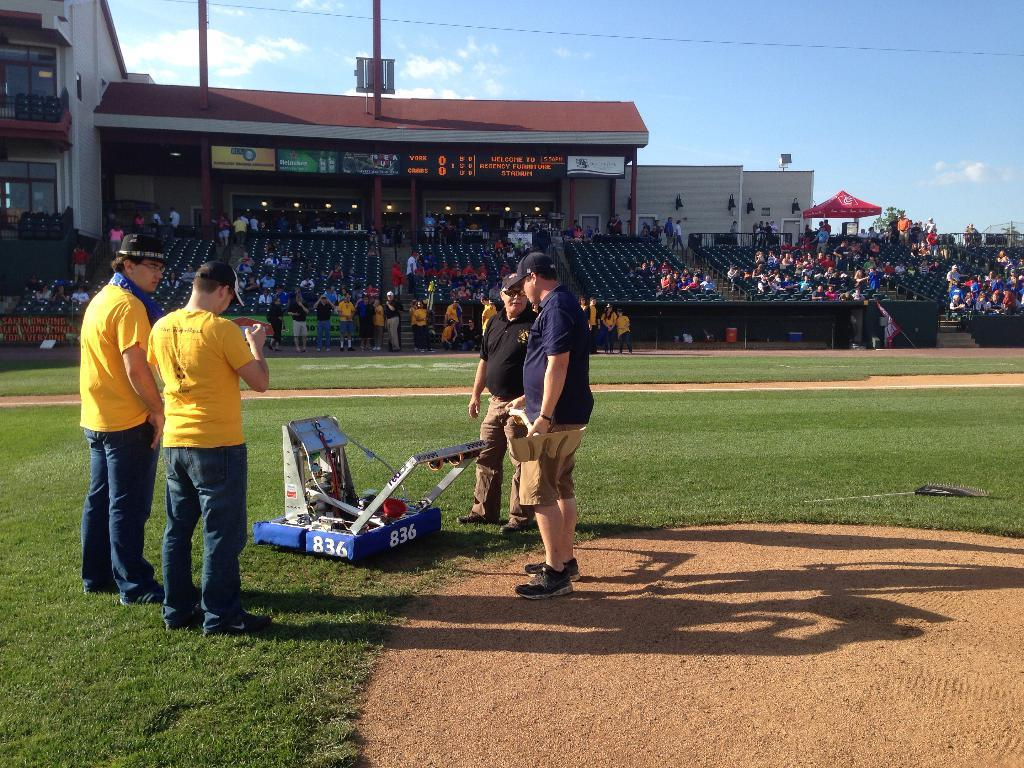How many people can be seen in the image? There are people in the image, but the exact number is not specified. What type of surface is visible in the image? There is grass in the image, which suggests a natural outdoor setting. What type of seating is available in the image? There are chairs in the image. What type of illumination is present in the image? There are lights in the image. What type of structure is visible in the image? There is a shed in the image. What type of temporary shelter is visible in the image? There is a tent in the image. What type of vertical supports are visible in the image? There are poles in the image. What type of linear object is visible in the image? There is a wire in the image. What other objects can be seen in the image? There are other objects in the image, but their specific nature is not specified. What is the condition of the sky in the image? The sky is cloudy in the image. What type of brake system is visible in the image? There is no brake system visible in the image. What type of slope can be seen in the image? There is no slope visible in the image. What type of leveling tool is visible in the image? There is no leveling tool visible in the image. 